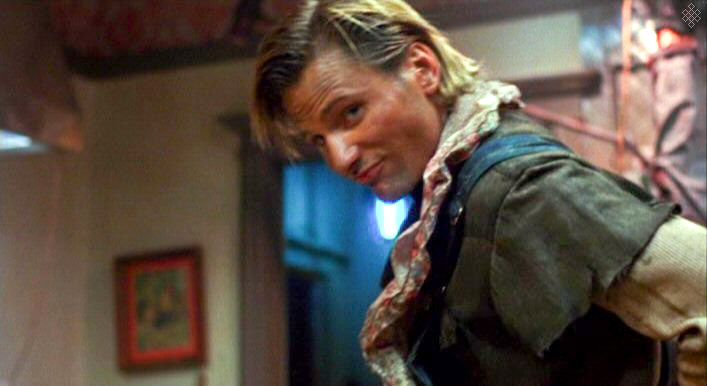Can you describe the style of clothing the man is wearing? The man is wearing a layered, eclectic style typical of rugged or historical settings. His beige jacket paired with a blue shirt and a colorful, patterned scarf provides a practical yet characterful look, suggesting a setting that might involve outdoor elements or historical contexts. 